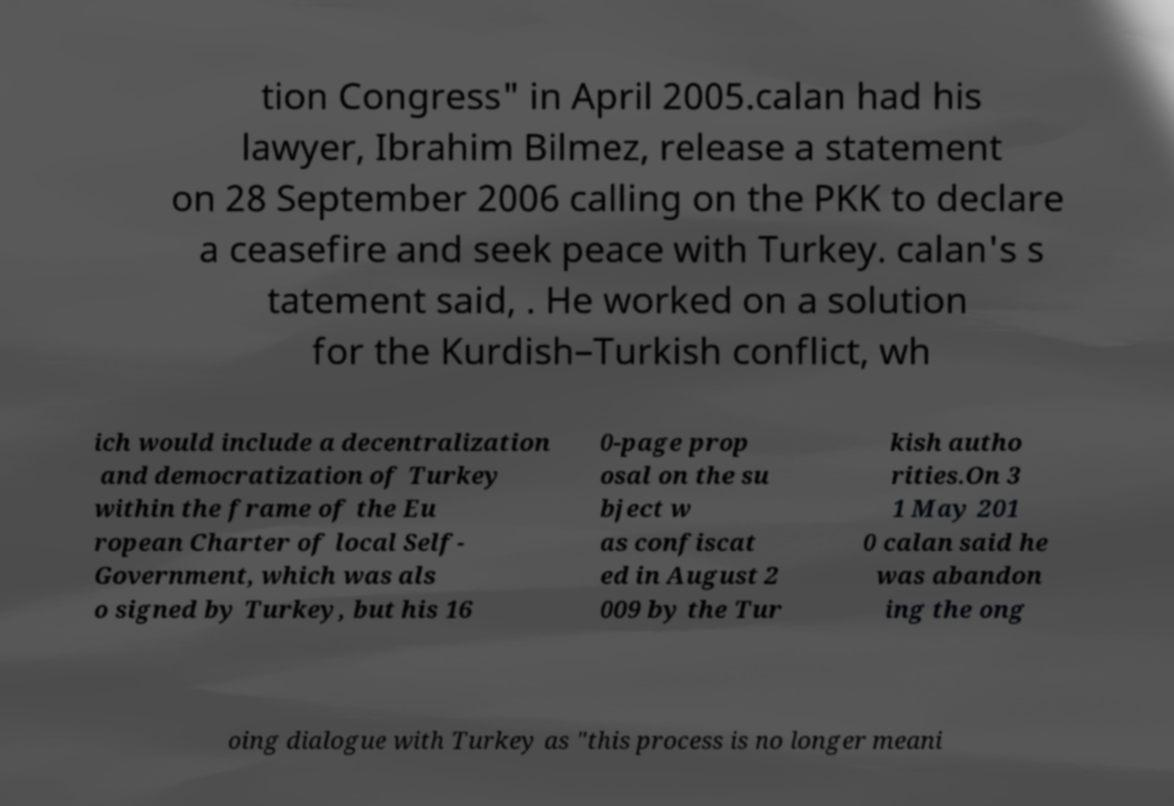What messages or text are displayed in this image? I need them in a readable, typed format. tion Congress" in April 2005.calan had his lawyer, Ibrahim Bilmez, release a statement on 28 September 2006 calling on the PKK to declare a ceasefire and seek peace with Turkey. calan's s tatement said, . He worked on a solution for the Kurdish–Turkish conflict, wh ich would include a decentralization and democratization of Turkey within the frame of the Eu ropean Charter of local Self- Government, which was als o signed by Turkey, but his 16 0-page prop osal on the su bject w as confiscat ed in August 2 009 by the Tur kish autho rities.On 3 1 May 201 0 calan said he was abandon ing the ong oing dialogue with Turkey as "this process is no longer meani 